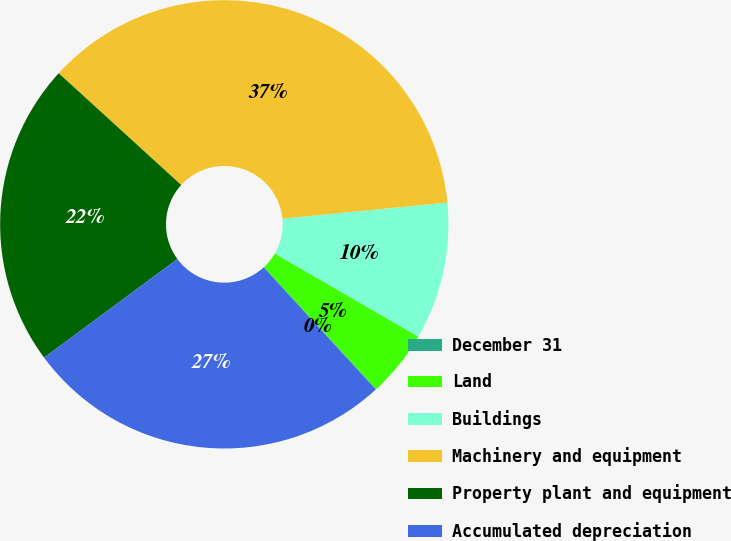<chart> <loc_0><loc_0><loc_500><loc_500><pie_chart><fcel>December 31<fcel>Land<fcel>Buildings<fcel>Machinery and equipment<fcel>Property plant and equipment<fcel>Accumulated depreciation<nl><fcel>0.03%<fcel>4.8%<fcel>9.9%<fcel>36.68%<fcel>21.91%<fcel>26.68%<nl></chart> 